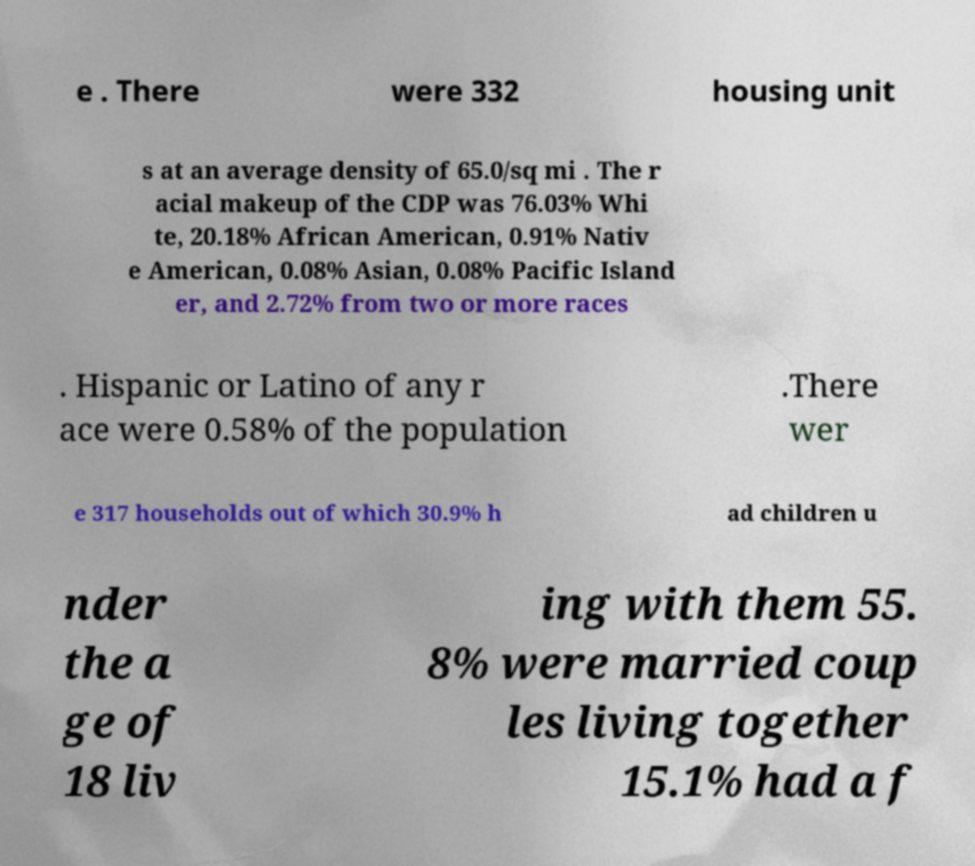Please identify and transcribe the text found in this image. e . There were 332 housing unit s at an average density of 65.0/sq mi . The r acial makeup of the CDP was 76.03% Whi te, 20.18% African American, 0.91% Nativ e American, 0.08% Asian, 0.08% Pacific Island er, and 2.72% from two or more races . Hispanic or Latino of any r ace were 0.58% of the population .There wer e 317 households out of which 30.9% h ad children u nder the a ge of 18 liv ing with them 55. 8% were married coup les living together 15.1% had a f 